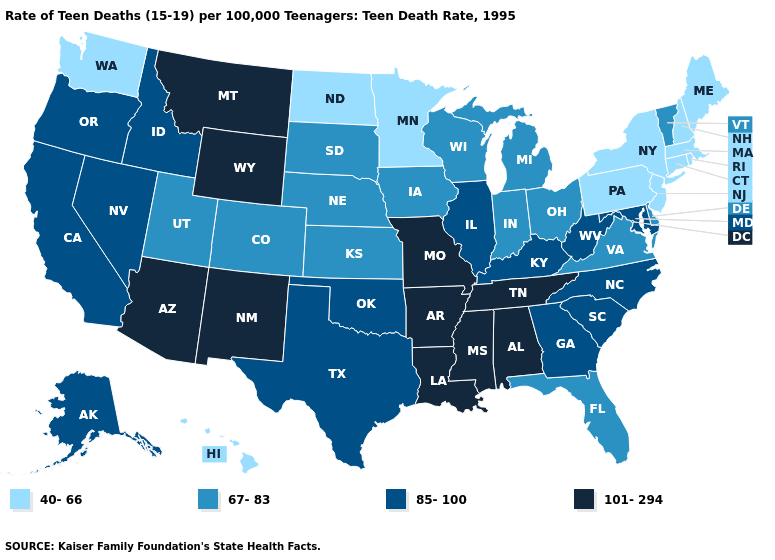Does Alabama have a higher value than Wisconsin?
Short answer required. Yes. What is the value of Alabama?
Concise answer only. 101-294. Name the states that have a value in the range 67-83?
Short answer required. Colorado, Delaware, Florida, Indiana, Iowa, Kansas, Michigan, Nebraska, Ohio, South Dakota, Utah, Vermont, Virginia, Wisconsin. What is the value of Maine?
Concise answer only. 40-66. What is the value of Illinois?
Keep it brief. 85-100. What is the value of Colorado?
Answer briefly. 67-83. What is the lowest value in the USA?
Concise answer only. 40-66. Which states have the lowest value in the USA?
Give a very brief answer. Connecticut, Hawaii, Maine, Massachusetts, Minnesota, New Hampshire, New Jersey, New York, North Dakota, Pennsylvania, Rhode Island, Washington. Does Virginia have the lowest value in the USA?
Be succinct. No. Does New Hampshire have the lowest value in the USA?
Quick response, please. Yes. Does Montana have the highest value in the West?
Give a very brief answer. Yes. Does the first symbol in the legend represent the smallest category?
Keep it brief. Yes. Does Mississippi have the lowest value in the USA?
Concise answer only. No. Name the states that have a value in the range 67-83?
Quick response, please. Colorado, Delaware, Florida, Indiana, Iowa, Kansas, Michigan, Nebraska, Ohio, South Dakota, Utah, Vermont, Virginia, Wisconsin. 